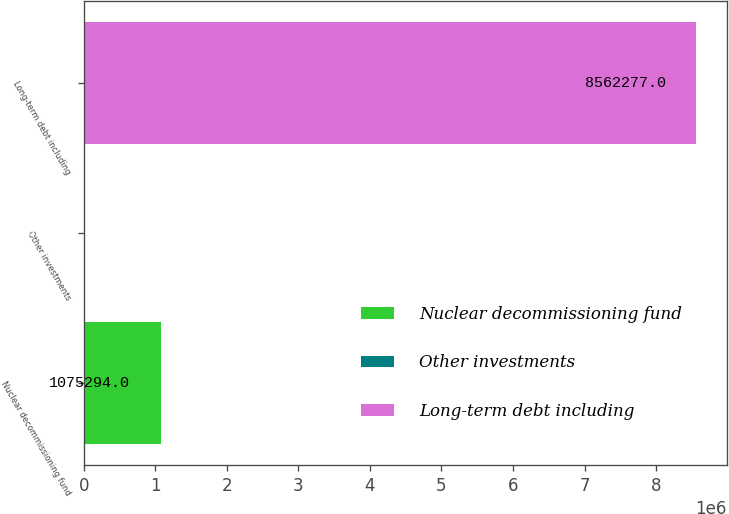<chart> <loc_0><loc_0><loc_500><loc_500><bar_chart><fcel>Nuclear decommissioning fund<fcel>Other investments<fcel>Long-term debt including<nl><fcel>1.07529e+06<fcel>9864<fcel>8.56228e+06<nl></chart> 